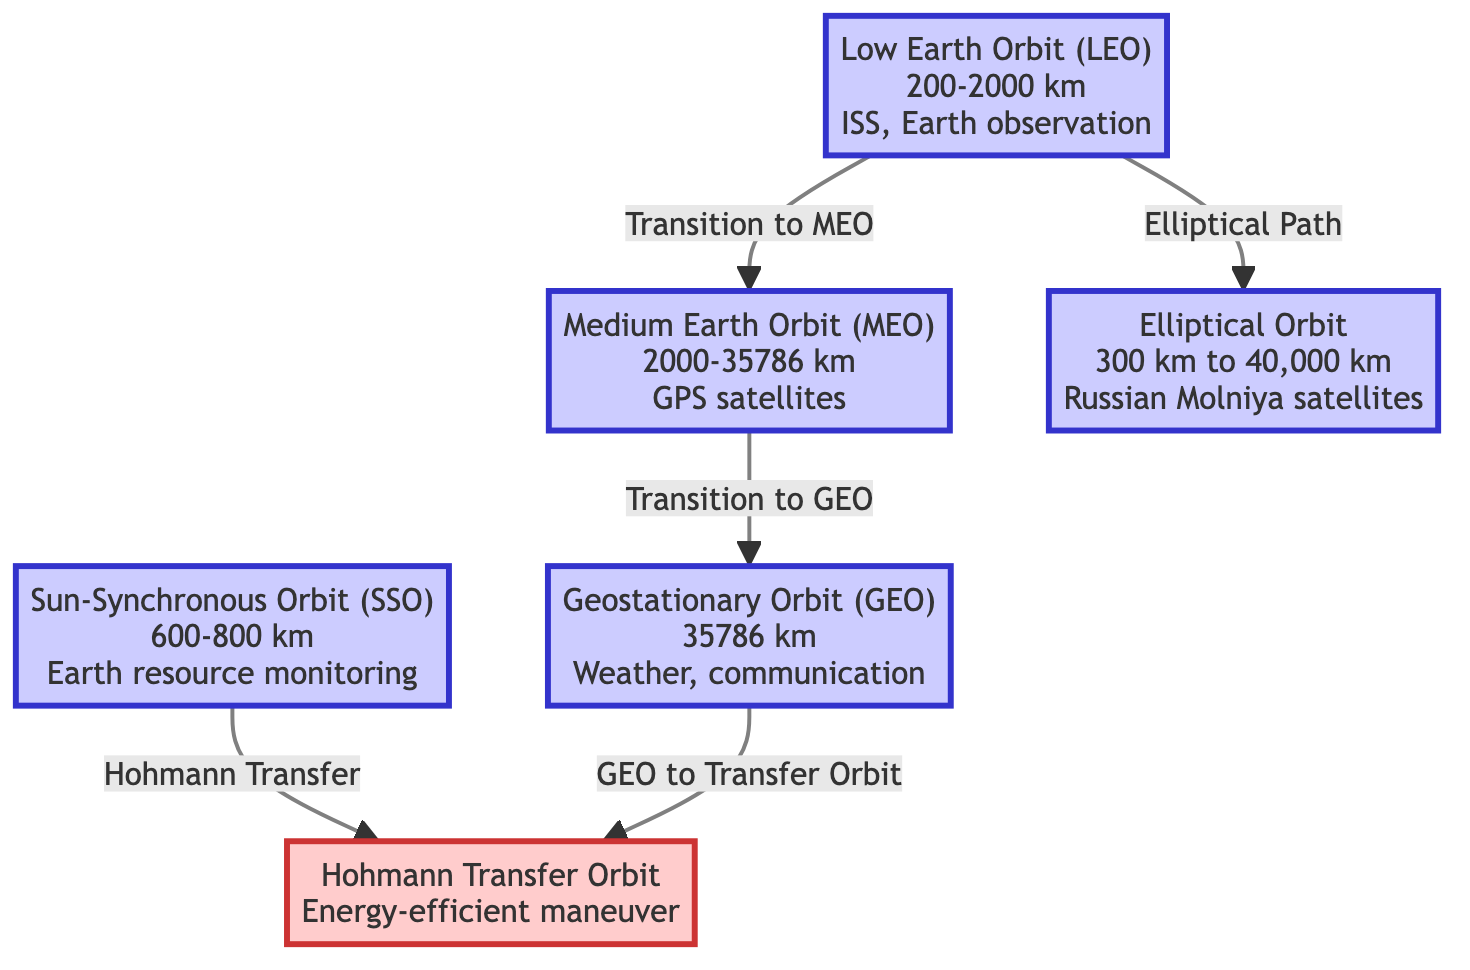What's the altitude range for Low Earth Orbit (LEO)? The diagram indicates that Low Earth Orbit (LEO) has an altitude range of 200-2000 km. This information can be directly found in the node labeled "Low Earth Orbit (LEO)".
Answer: 200-2000 km What type of orbit is utilized for GPS satellites? From the diagram, it is clear that Medium Earth Orbit (MEO) is designated for GPS satellites. This information is presented in the MEO node.
Answer: Medium Earth Orbit (MEO) Which orbit has the highest altitude? Geostationary Orbit (GEO) has the highest altitude listed in the diagram at 35786 km. This altitude can be seen in the relevant node for GEO.
Answer: 35786 km What is the transition from Low Earth Orbit (LEO) to Medium Earth Orbit (MEO)? The transition is labeled as "Transition to MEO" in the diagram, which connects the LEO node to the MEO node. This specifically describes the movement from LEO to MEO.
Answer: Transition to MEO What is the function of the Hohmann Transfer Orbit? The Hohmann Transfer Orbit is described within the diagram as an "Energy-efficient maneuver". This description is found in the node that contains the Hohmann Transfer Orbit information.
Answer: Energy-efficient maneuver What type of orbit do Russian Molniya satellites utilize? The diagram identifies that Russian Molniya satellites operate in an Elliptical Orbit, which is displayed in the node dedicated to that orbit type.
Answer: Elliptical Orbit How many types of orbits are listed in the diagram? The diagram clearly presents six orbit types, which can be counted through the nodes labeled from LEO to Hohmann Transfer Orbit.
Answer: 6 What orbit is used for Earth resource monitoring? The diagram indicates that the orbit used for Earth resource monitoring is the Sun-Synchronous Orbit (SSO), which is specified in the corresponding node.
Answer: Sun-Synchronous Orbit (SSO) What is the relationship between Geostationary Orbit (GEO) and Hohmann Transfer Orbit? The diagram illustrates that there is a transition labeled "GEO to Transfer Orbit" connecting the GEO node to the Hohmann Transfer Orbit node, indicating a relationship of maneuvering.
Answer: GEO to Transfer Orbit 